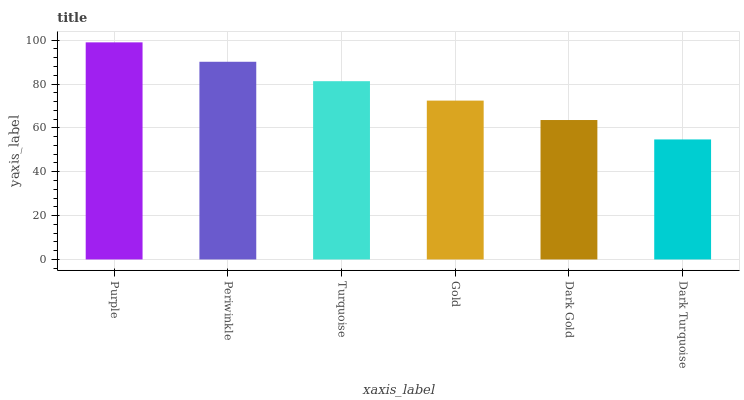Is Dark Turquoise the minimum?
Answer yes or no. Yes. Is Purple the maximum?
Answer yes or no. Yes. Is Periwinkle the minimum?
Answer yes or no. No. Is Periwinkle the maximum?
Answer yes or no. No. Is Purple greater than Periwinkle?
Answer yes or no. Yes. Is Periwinkle less than Purple?
Answer yes or no. Yes. Is Periwinkle greater than Purple?
Answer yes or no. No. Is Purple less than Periwinkle?
Answer yes or no. No. Is Turquoise the high median?
Answer yes or no. Yes. Is Gold the low median?
Answer yes or no. Yes. Is Gold the high median?
Answer yes or no. No. Is Turquoise the low median?
Answer yes or no. No. 